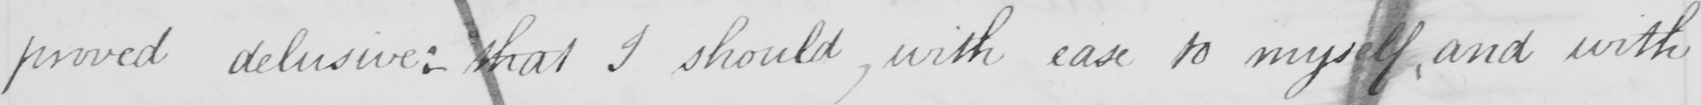Transcribe the text shown in this historical manuscript line. proved delusive: that I should with ease to myself and with 